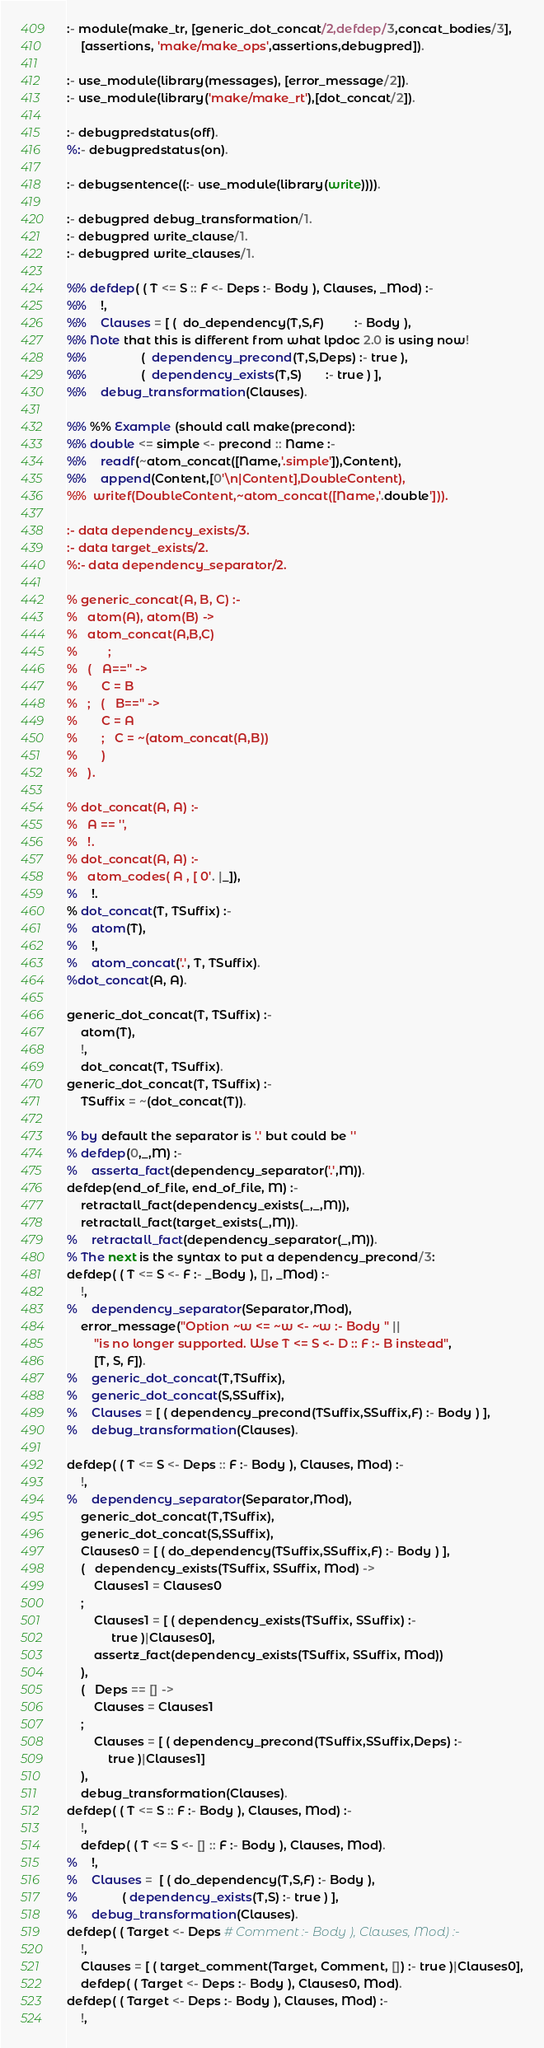Convert code to text. <code><loc_0><loc_0><loc_500><loc_500><_Perl_>:- module(make_tr, [generic_dot_concat/2,defdep/3,concat_bodies/3],
	[assertions, 'make/make_ops',assertions,debugpred]).

:- use_module(library(messages), [error_message/2]).
:- use_module(library('make/make_rt'),[dot_concat/2]).

:- debugpredstatus(off).
%:- debugpredstatus(on).

:- debugsentence((:- use_module(library(write)))).

:- debugpred debug_transformation/1.
:- debugpred write_clause/1.
:- debugpred write_clauses/1.

%% defdep( ( T <= S :: F <- Deps :- Body ), Clauses, _Mod) :- 
%% 	!,
%% 	Clauses = [ (  do_dependency(T,S,F)         :- Body ), 
%% Note that this is different from what lpdoc 2.0 is using now!
%% 	            (  dependency_precond(T,S,Deps) :- true ), 
%% 	            (  dependency_exists(T,S)       :- true ) ], 
%% 	debug_transformation(Clauses).

%% %% Example (should call make(precond):
%% double <= simple <- precond :: Name :-
%% 	readf(~atom_concat([Name,'.simple']),Content),
%% 	append(Content,[0'\n|Content],DoubleContent),
%% 	writef(DoubleContent,~atom_concat([Name,'.double'])).

:- data dependency_exists/3.
:- data target_exists/2.
%:- data dependency_separator/2.

% generic_concat(A, B, C) :-
% 	atom(A), atom(B) ->
% 	atom_concat(A,B,C)
%         ;
% 	(   A=='' ->
% 	    C = B
% 	;   (   B=='' ->
% 		C = A
% 	    ;	C = ~(atom_concat(A,B))
% 	    )
% 	).

% dot_concat(A, A) :-
% 	A == '',
% 	!.
% dot_concat(A, A) :-
% 	atom_codes( A , [ 0'. |_]),
% 	!.
% dot_concat(T, TSuffix) :-
% 	atom(T),
% 	!,
% 	atom_concat('.', T, TSuffix).
%dot_concat(A, A).

generic_dot_concat(T, TSuffix) :-
	atom(T),
	!,
	dot_concat(T, TSuffix).
generic_dot_concat(T, TSuffix) :-
	TSuffix = ~(dot_concat(T)).

% by default the separator is '.' but could be ''
% defdep(0,_,M) :-
% 	asserta_fact(dependency_separator('.',M)).
defdep(end_of_file, end_of_file, M) :-
	retractall_fact(dependency_exists(_,_,M)),
	retractall_fact(target_exists(_,M)).
%	retractall_fact(dependency_separator(_,M)).
% The next is the syntax to put a dependency_precond/3:
defdep( ( T <= S <- F :- _Body ), [], _Mod) :-
	!,
%	dependency_separator(Separator,Mod),
	error_message("Option ~w <= ~w <- ~w :- Body " ||
	    "is no longer supported. Wse T <= S <- D :: F :- B instead",
	    [T, S, F]).
%	generic_dot_concat(T,TSuffix),
%	generic_dot_concat(S,SSuffix),
%	Clauses = [ ( dependency_precond(TSuffix,SSuffix,F) :- Body ) ],
%	debug_transformation(Clauses).

defdep( ( T <= S <- Deps :: F :- Body ), Clauses, Mod) :-
	!,
%	dependency_separator(Separator,Mod),
	generic_dot_concat(T,TSuffix),
	generic_dot_concat(S,SSuffix),
	Clauses0 = [ ( do_dependency(TSuffix,SSuffix,F) :- Body ) ],
	(   dependency_exists(TSuffix, SSuffix, Mod) ->
	    Clauses1 = Clauses0
	;
	    Clauses1 = [ ( dependency_exists(TSuffix, SSuffix) :- 
			 true )|Clauses0],
	    assertz_fact(dependency_exists(TSuffix, SSuffix, Mod))
	),
	(   Deps == [] ->
	    Clauses = Clauses1
	;
	    Clauses = [ ( dependency_precond(TSuffix,SSuffix,Deps) :-
			true )|Clauses1]
	),
	debug_transformation(Clauses).
defdep( ( T <= S :: F :- Body ), Clauses, Mod) :-
	!,
	defdep( ( T <= S <- [] :: F :- Body ), Clauses, Mod).
% 	!,
% 	Clauses =  [ ( do_dependency(T,S,F) :- Body ),
% 		     ( dependency_exists(T,S) :- true ) ],
% 	debug_transformation(Clauses).
defdep( ( Target <- Deps # Comment :- Body ), Clauses, Mod) :-
	!,
	Clauses = [ ( target_comment(Target, Comment, []) :- true )|Clauses0],
	defdep( ( Target <- Deps :- Body ), Clauses0, Mod).
defdep( ( Target <- Deps :- Body ), Clauses, Mod) :-
	!,</code> 